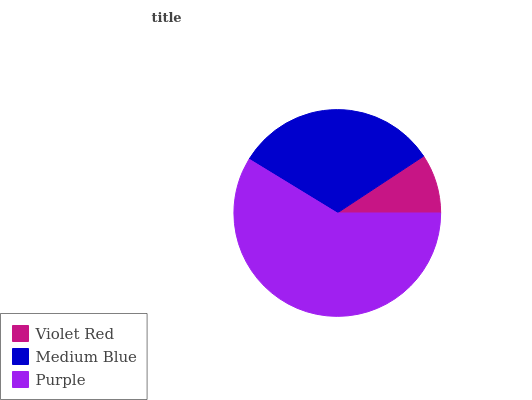Is Violet Red the minimum?
Answer yes or no. Yes. Is Purple the maximum?
Answer yes or no. Yes. Is Medium Blue the minimum?
Answer yes or no. No. Is Medium Blue the maximum?
Answer yes or no. No. Is Medium Blue greater than Violet Red?
Answer yes or no. Yes. Is Violet Red less than Medium Blue?
Answer yes or no. Yes. Is Violet Red greater than Medium Blue?
Answer yes or no. No. Is Medium Blue less than Violet Red?
Answer yes or no. No. Is Medium Blue the high median?
Answer yes or no. Yes. Is Medium Blue the low median?
Answer yes or no. Yes. Is Purple the high median?
Answer yes or no. No. Is Purple the low median?
Answer yes or no. No. 